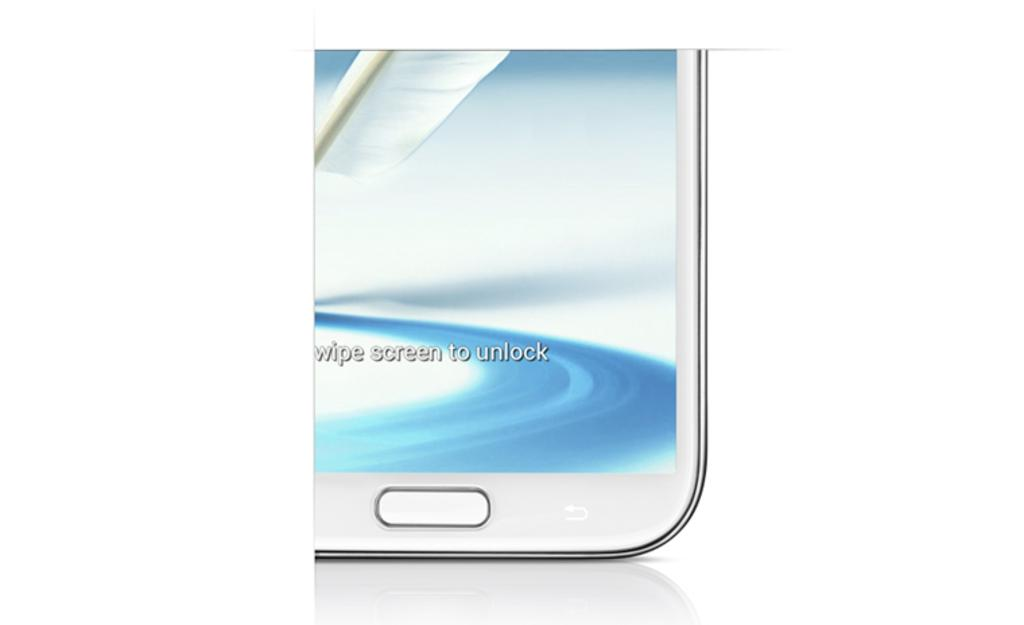<image>
Render a clear and concise summary of the photo. a close up of an ad that reads Swipe screen to unlock 